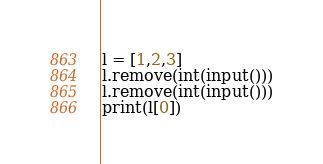Convert code to text. <code><loc_0><loc_0><loc_500><loc_500><_Python_>l = [1,2,3]
l.remove(int(input()))
l.remove(int(input()))
print(l[0])</code> 